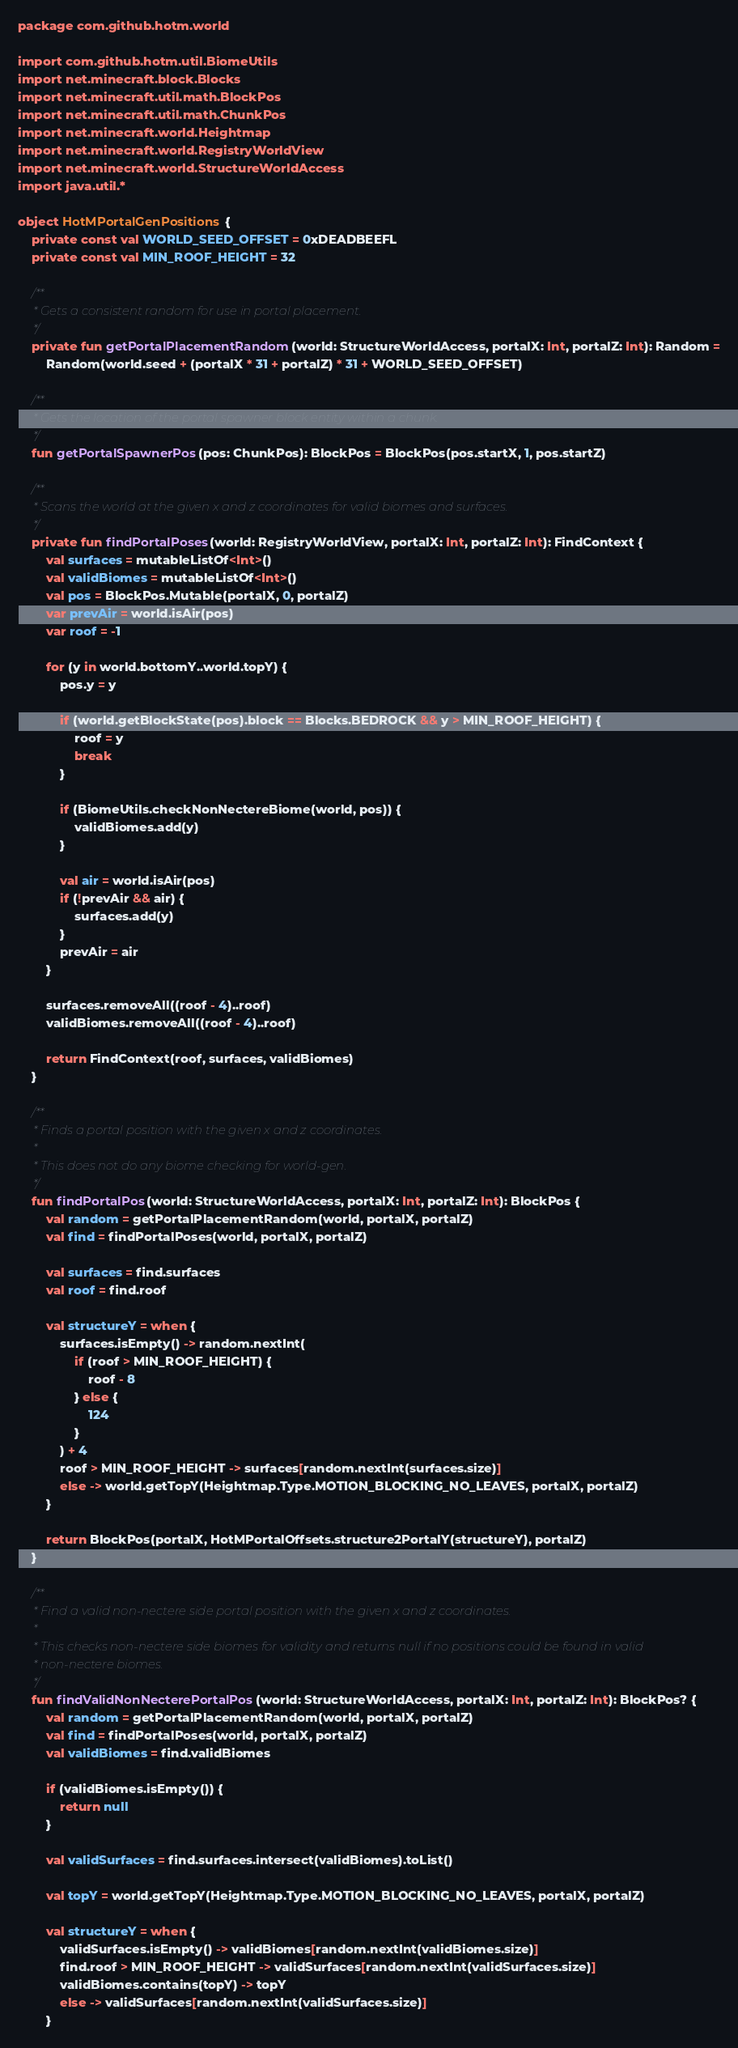Convert code to text. <code><loc_0><loc_0><loc_500><loc_500><_Kotlin_>package com.github.hotm.world

import com.github.hotm.util.BiomeUtils
import net.minecraft.block.Blocks
import net.minecraft.util.math.BlockPos
import net.minecraft.util.math.ChunkPos
import net.minecraft.world.Heightmap
import net.minecraft.world.RegistryWorldView
import net.minecraft.world.StructureWorldAccess
import java.util.*

object HotMPortalGenPositions {
    private const val WORLD_SEED_OFFSET = 0xDEADBEEFL
    private const val MIN_ROOF_HEIGHT = 32

    /**
     * Gets a consistent random for use in portal placement.
     */
    private fun getPortalPlacementRandom(world: StructureWorldAccess, portalX: Int, portalZ: Int): Random =
        Random(world.seed + (portalX * 31 + portalZ) * 31 + WORLD_SEED_OFFSET)

    /**
     * Gets the location of the portal spawner block entity within a chunk.
     */
    fun getPortalSpawnerPos(pos: ChunkPos): BlockPos = BlockPos(pos.startX, 1, pos.startZ)

    /**
     * Scans the world at the given x and z coordinates for valid biomes and surfaces.
     */
    private fun findPortalPoses(world: RegistryWorldView, portalX: Int, portalZ: Int): FindContext {
        val surfaces = mutableListOf<Int>()
        val validBiomes = mutableListOf<Int>()
        val pos = BlockPos.Mutable(portalX, 0, portalZ)
        var prevAir = world.isAir(pos)
        var roof = -1

        for (y in world.bottomY..world.topY) {
            pos.y = y

            if (world.getBlockState(pos).block == Blocks.BEDROCK && y > MIN_ROOF_HEIGHT) {
                roof = y
                break
            }

            if (BiomeUtils.checkNonNectereBiome(world, pos)) {
                validBiomes.add(y)
            }

            val air = world.isAir(pos)
            if (!prevAir && air) {
                surfaces.add(y)
            }
            prevAir = air
        }

        surfaces.removeAll((roof - 4)..roof)
        validBiomes.removeAll((roof - 4)..roof)

        return FindContext(roof, surfaces, validBiomes)
    }

    /**
     * Finds a portal position with the given x and z coordinates.
     *
     * This does not do any biome checking for world-gen.
     */
    fun findPortalPos(world: StructureWorldAccess, portalX: Int, portalZ: Int): BlockPos {
        val random = getPortalPlacementRandom(world, portalX, portalZ)
        val find = findPortalPoses(world, portalX, portalZ)

        val surfaces = find.surfaces
        val roof = find.roof

        val structureY = when {
            surfaces.isEmpty() -> random.nextInt(
                if (roof > MIN_ROOF_HEIGHT) {
                    roof - 8
                } else {
                    124
                }
            ) + 4
            roof > MIN_ROOF_HEIGHT -> surfaces[random.nextInt(surfaces.size)]
            else -> world.getTopY(Heightmap.Type.MOTION_BLOCKING_NO_LEAVES, portalX, portalZ)
        }

        return BlockPos(portalX, HotMPortalOffsets.structure2PortalY(structureY), portalZ)
    }

    /**
     * Find a valid non-nectere side portal position with the given x and z coordinates.
     *
     * This checks non-nectere side biomes for validity and returns null if no positions could be found in valid
     * non-nectere biomes.
     */
    fun findValidNonNecterePortalPos(world: StructureWorldAccess, portalX: Int, portalZ: Int): BlockPos? {
        val random = getPortalPlacementRandom(world, portalX, portalZ)
        val find = findPortalPoses(world, portalX, portalZ)
        val validBiomes = find.validBiomes

        if (validBiomes.isEmpty()) {
            return null
        }

        val validSurfaces = find.surfaces.intersect(validBiomes).toList()

        val topY = world.getTopY(Heightmap.Type.MOTION_BLOCKING_NO_LEAVES, portalX, portalZ)

        val structureY = when {
            validSurfaces.isEmpty() -> validBiomes[random.nextInt(validBiomes.size)]
            find.roof > MIN_ROOF_HEIGHT -> validSurfaces[random.nextInt(validSurfaces.size)]
            validBiomes.contains(topY) -> topY
            else -> validSurfaces[random.nextInt(validSurfaces.size)]
        }
</code> 